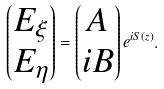Convert formula to latex. <formula><loc_0><loc_0><loc_500><loc_500>\begin{pmatrix} E _ { \xi } \\ E _ { \eta } \\ \end{pmatrix} = \begin{pmatrix} A \\ i B \\ \end{pmatrix} e ^ { i S ( z ) } .</formula> 